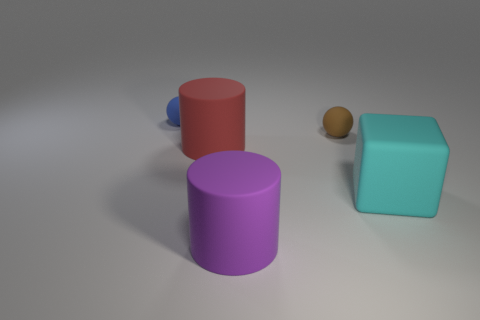Are there fewer blue matte objects behind the large cyan rubber thing than yellow blocks?
Your answer should be very brief. No. The small ball that is to the right of the small object behind the brown rubber sphere is what color?
Your answer should be very brief. Brown. There is a matte object right of the ball in front of the sphere on the left side of the red thing; what size is it?
Ensure brevity in your answer.  Large. Is the number of rubber cubes that are left of the large matte cube less than the number of large red rubber things right of the large red matte cylinder?
Your answer should be compact. No. What number of cyan objects have the same material as the large red cylinder?
Your answer should be very brief. 1. Is there a big rubber cylinder that is in front of the thing that is to the right of the matte sphere that is to the right of the tiny blue ball?
Make the answer very short. Yes. There is a red object that is the same material as the big cube; what shape is it?
Your response must be concise. Cylinder. Is the number of large red objects greater than the number of rubber cylinders?
Ensure brevity in your answer.  No. There is a small brown matte object; does it have the same shape as the rubber thing that is in front of the block?
Offer a very short reply. No. What material is the blue thing?
Your response must be concise. Rubber. 